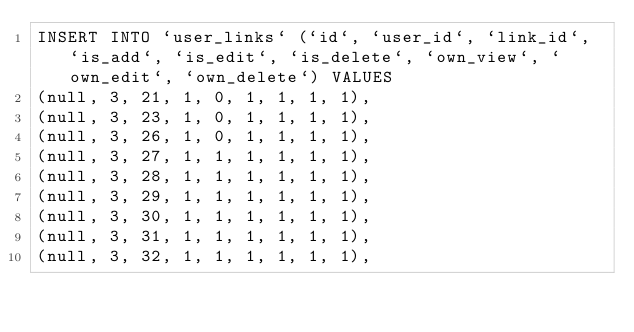<code> <loc_0><loc_0><loc_500><loc_500><_SQL_>INSERT INTO `user_links` (`id`, `user_id`, `link_id`, `is_add`, `is_edit`, `is_delete`, `own_view`, `own_edit`, `own_delete`) VALUES
(null, 3, 21, 1, 0, 1, 1, 1, 1),
(null, 3, 23, 1, 0, 1, 1, 1, 1),
(null, 3, 26, 1, 0, 1, 1, 1, 1),
(null, 3, 27, 1, 1, 1, 1, 1, 1),
(null, 3, 28, 1, 1, 1, 1, 1, 1),
(null, 3, 29, 1, 1, 1, 1, 1, 1),
(null, 3, 30, 1, 1, 1, 1, 1, 1),
(null, 3, 31, 1, 1, 1, 1, 1, 1),
(null, 3, 32, 1, 1, 1, 1, 1, 1),</code> 